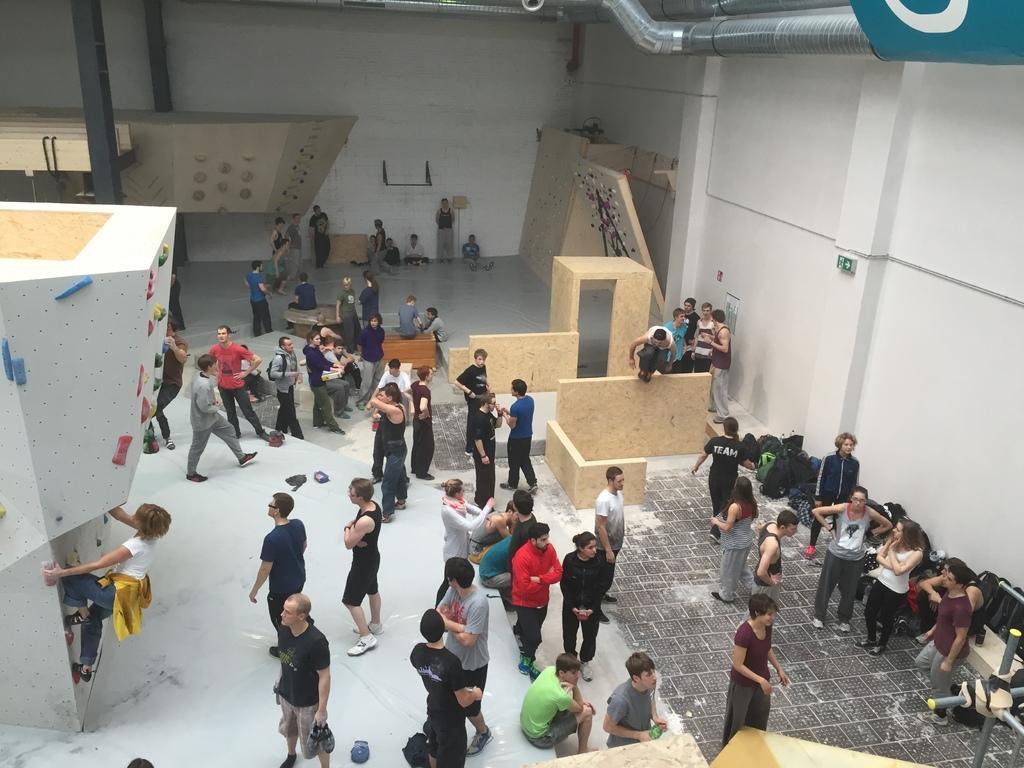Describe this image in one or two sentences. This picture shows inner view of a building and I can see few people standing and few are sitting and I can see a woman climbing a wall, it looks like bouldering. 